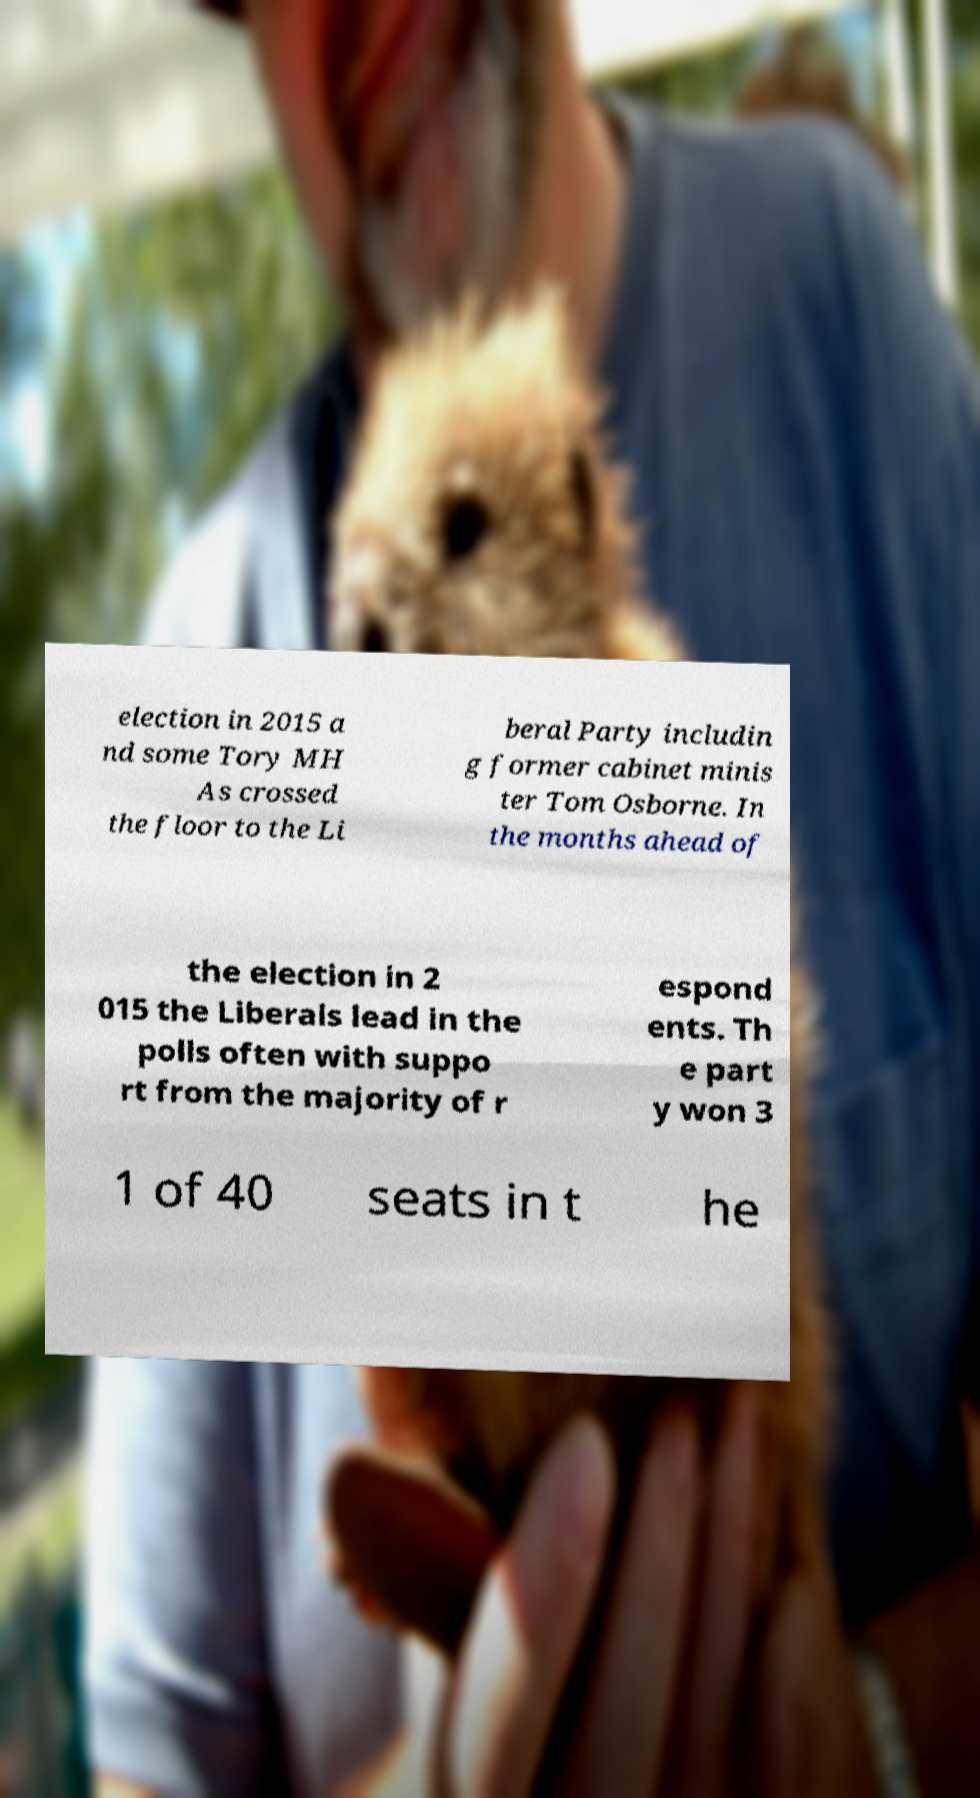Please identify and transcribe the text found in this image. election in 2015 a nd some Tory MH As crossed the floor to the Li beral Party includin g former cabinet minis ter Tom Osborne. In the months ahead of the election in 2 015 the Liberals lead in the polls often with suppo rt from the majority of r espond ents. Th e part y won 3 1 of 40 seats in t he 